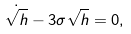<formula> <loc_0><loc_0><loc_500><loc_500>\dot { \sqrt { h } } - 3 \sigma \sqrt { h } = 0 ,</formula> 